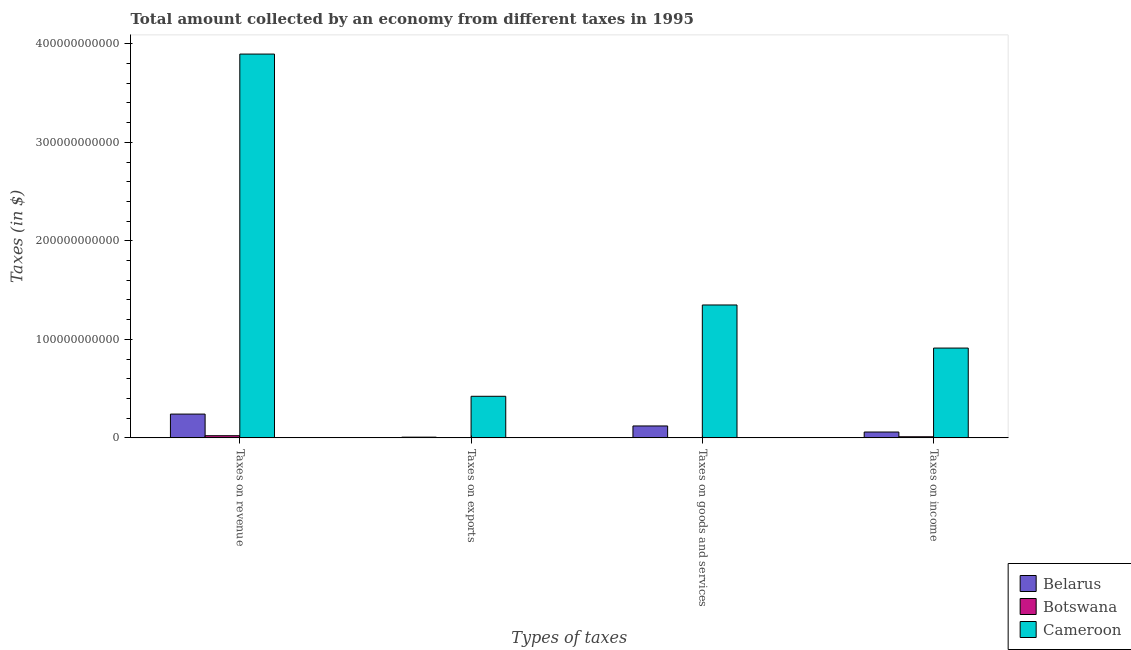How many groups of bars are there?
Your response must be concise. 4. Are the number of bars on each tick of the X-axis equal?
Give a very brief answer. Yes. How many bars are there on the 3rd tick from the left?
Your answer should be very brief. 3. How many bars are there on the 4th tick from the right?
Offer a very short reply. 3. What is the label of the 1st group of bars from the left?
Your answer should be compact. Taxes on revenue. What is the amount collected as tax on revenue in Cameroon?
Your answer should be compact. 3.90e+11. Across all countries, what is the maximum amount collected as tax on income?
Your answer should be very brief. 9.12e+1. Across all countries, what is the minimum amount collected as tax on revenue?
Give a very brief answer. 2.20e+09. In which country was the amount collected as tax on exports maximum?
Offer a terse response. Cameroon. In which country was the amount collected as tax on income minimum?
Ensure brevity in your answer.  Botswana. What is the total amount collected as tax on goods in the graph?
Ensure brevity in your answer.  1.47e+11. What is the difference between the amount collected as tax on exports in Cameroon and that in Belarus?
Make the answer very short. 4.15e+1. What is the difference between the amount collected as tax on exports in Botswana and the amount collected as tax on income in Belarus?
Give a very brief answer. -5.93e+09. What is the average amount collected as tax on exports per country?
Offer a terse response. 1.43e+1. What is the difference between the amount collected as tax on goods and amount collected as tax on exports in Belarus?
Your response must be concise. 1.14e+1. What is the ratio of the amount collected as tax on exports in Botswana to that in Belarus?
Your answer should be compact. 0. Is the amount collected as tax on goods in Cameroon less than that in Botswana?
Ensure brevity in your answer.  No. What is the difference between the highest and the second highest amount collected as tax on income?
Your answer should be compact. 8.52e+1. What is the difference between the highest and the lowest amount collected as tax on exports?
Ensure brevity in your answer.  4.22e+1. Is the sum of the amount collected as tax on goods in Belarus and Botswana greater than the maximum amount collected as tax on income across all countries?
Make the answer very short. No. What does the 1st bar from the left in Taxes on goods and services represents?
Ensure brevity in your answer.  Belarus. What does the 2nd bar from the right in Taxes on revenue represents?
Provide a succinct answer. Botswana. Is it the case that in every country, the sum of the amount collected as tax on revenue and amount collected as tax on exports is greater than the amount collected as tax on goods?
Offer a terse response. Yes. What is the difference between two consecutive major ticks on the Y-axis?
Provide a succinct answer. 1.00e+11. Are the values on the major ticks of Y-axis written in scientific E-notation?
Keep it short and to the point. No. How are the legend labels stacked?
Offer a terse response. Vertical. What is the title of the graph?
Ensure brevity in your answer.  Total amount collected by an economy from different taxes in 1995. Does "Iraq" appear as one of the legend labels in the graph?
Ensure brevity in your answer.  No. What is the label or title of the X-axis?
Ensure brevity in your answer.  Types of taxes. What is the label or title of the Y-axis?
Give a very brief answer. Taxes (in $). What is the Taxes (in $) in Belarus in Taxes on revenue?
Your response must be concise. 2.41e+1. What is the Taxes (in $) in Botswana in Taxes on revenue?
Give a very brief answer. 2.20e+09. What is the Taxes (in $) in Cameroon in Taxes on revenue?
Offer a terse response. 3.90e+11. What is the Taxes (in $) in Belarus in Taxes on exports?
Keep it short and to the point. 7.31e+08. What is the Taxes (in $) in Cameroon in Taxes on exports?
Provide a succinct answer. 4.22e+1. What is the Taxes (in $) of Belarus in Taxes on goods and services?
Offer a terse response. 1.21e+1. What is the Taxes (in $) of Botswana in Taxes on goods and services?
Offer a very short reply. 2.38e+08. What is the Taxes (in $) in Cameroon in Taxes on goods and services?
Make the answer very short. 1.35e+11. What is the Taxes (in $) of Belarus in Taxes on income?
Offer a very short reply. 5.93e+09. What is the Taxes (in $) in Botswana in Taxes on income?
Offer a terse response. 1.13e+09. What is the Taxes (in $) of Cameroon in Taxes on income?
Your response must be concise. 9.12e+1. Across all Types of taxes, what is the maximum Taxes (in $) in Belarus?
Provide a succinct answer. 2.41e+1. Across all Types of taxes, what is the maximum Taxes (in $) in Botswana?
Offer a terse response. 2.20e+09. Across all Types of taxes, what is the maximum Taxes (in $) of Cameroon?
Ensure brevity in your answer.  3.90e+11. Across all Types of taxes, what is the minimum Taxes (in $) in Belarus?
Give a very brief answer. 7.31e+08. Across all Types of taxes, what is the minimum Taxes (in $) in Cameroon?
Provide a succinct answer. 4.22e+1. What is the total Taxes (in $) in Belarus in the graph?
Ensure brevity in your answer.  4.29e+1. What is the total Taxes (in $) in Botswana in the graph?
Provide a short and direct response. 3.56e+09. What is the total Taxes (in $) of Cameroon in the graph?
Your answer should be very brief. 6.58e+11. What is the difference between the Taxes (in $) in Belarus in Taxes on revenue and that in Taxes on exports?
Ensure brevity in your answer.  2.34e+1. What is the difference between the Taxes (in $) of Botswana in Taxes on revenue and that in Taxes on exports?
Provide a short and direct response. 2.20e+09. What is the difference between the Taxes (in $) of Cameroon in Taxes on revenue and that in Taxes on exports?
Keep it short and to the point. 3.47e+11. What is the difference between the Taxes (in $) in Belarus in Taxes on revenue and that in Taxes on goods and services?
Provide a succinct answer. 1.20e+1. What is the difference between the Taxes (in $) of Botswana in Taxes on revenue and that in Taxes on goods and services?
Offer a terse response. 1.96e+09. What is the difference between the Taxes (in $) in Cameroon in Taxes on revenue and that in Taxes on goods and services?
Provide a short and direct response. 2.55e+11. What is the difference between the Taxes (in $) in Belarus in Taxes on revenue and that in Taxes on income?
Your response must be concise. 1.82e+1. What is the difference between the Taxes (in $) in Botswana in Taxes on revenue and that in Taxes on income?
Offer a very short reply. 1.07e+09. What is the difference between the Taxes (in $) of Cameroon in Taxes on revenue and that in Taxes on income?
Ensure brevity in your answer.  2.98e+11. What is the difference between the Taxes (in $) of Belarus in Taxes on exports and that in Taxes on goods and services?
Make the answer very short. -1.14e+1. What is the difference between the Taxes (in $) of Botswana in Taxes on exports and that in Taxes on goods and services?
Your answer should be very brief. -2.37e+08. What is the difference between the Taxes (in $) in Cameroon in Taxes on exports and that in Taxes on goods and services?
Your response must be concise. -9.27e+1. What is the difference between the Taxes (in $) of Belarus in Taxes on exports and that in Taxes on income?
Provide a succinct answer. -5.20e+09. What is the difference between the Taxes (in $) of Botswana in Taxes on exports and that in Taxes on income?
Ensure brevity in your answer.  -1.13e+09. What is the difference between the Taxes (in $) in Cameroon in Taxes on exports and that in Taxes on income?
Give a very brief answer. -4.89e+1. What is the difference between the Taxes (in $) in Belarus in Taxes on goods and services and that in Taxes on income?
Your answer should be very brief. 6.16e+09. What is the difference between the Taxes (in $) of Botswana in Taxes on goods and services and that in Taxes on income?
Offer a terse response. -8.90e+08. What is the difference between the Taxes (in $) in Cameroon in Taxes on goods and services and that in Taxes on income?
Make the answer very short. 4.37e+1. What is the difference between the Taxes (in $) in Belarus in Taxes on revenue and the Taxes (in $) in Botswana in Taxes on exports?
Your answer should be very brief. 2.41e+1. What is the difference between the Taxes (in $) of Belarus in Taxes on revenue and the Taxes (in $) of Cameroon in Taxes on exports?
Make the answer very short. -1.81e+1. What is the difference between the Taxes (in $) of Botswana in Taxes on revenue and the Taxes (in $) of Cameroon in Taxes on exports?
Provide a short and direct response. -4.00e+1. What is the difference between the Taxes (in $) in Belarus in Taxes on revenue and the Taxes (in $) in Botswana in Taxes on goods and services?
Give a very brief answer. 2.39e+1. What is the difference between the Taxes (in $) in Belarus in Taxes on revenue and the Taxes (in $) in Cameroon in Taxes on goods and services?
Offer a terse response. -1.11e+11. What is the difference between the Taxes (in $) in Botswana in Taxes on revenue and the Taxes (in $) in Cameroon in Taxes on goods and services?
Provide a succinct answer. -1.33e+11. What is the difference between the Taxes (in $) in Belarus in Taxes on revenue and the Taxes (in $) in Botswana in Taxes on income?
Your answer should be very brief. 2.30e+1. What is the difference between the Taxes (in $) in Belarus in Taxes on revenue and the Taxes (in $) in Cameroon in Taxes on income?
Your answer should be compact. -6.70e+1. What is the difference between the Taxes (in $) of Botswana in Taxes on revenue and the Taxes (in $) of Cameroon in Taxes on income?
Offer a very short reply. -8.90e+1. What is the difference between the Taxes (in $) in Belarus in Taxes on exports and the Taxes (in $) in Botswana in Taxes on goods and services?
Give a very brief answer. 4.94e+08. What is the difference between the Taxes (in $) in Belarus in Taxes on exports and the Taxes (in $) in Cameroon in Taxes on goods and services?
Give a very brief answer. -1.34e+11. What is the difference between the Taxes (in $) of Botswana in Taxes on exports and the Taxes (in $) of Cameroon in Taxes on goods and services?
Ensure brevity in your answer.  -1.35e+11. What is the difference between the Taxes (in $) of Belarus in Taxes on exports and the Taxes (in $) of Botswana in Taxes on income?
Offer a terse response. -3.96e+08. What is the difference between the Taxes (in $) of Belarus in Taxes on exports and the Taxes (in $) of Cameroon in Taxes on income?
Your response must be concise. -9.04e+1. What is the difference between the Taxes (in $) in Botswana in Taxes on exports and the Taxes (in $) in Cameroon in Taxes on income?
Your answer should be compact. -9.11e+1. What is the difference between the Taxes (in $) of Belarus in Taxes on goods and services and the Taxes (in $) of Botswana in Taxes on income?
Offer a terse response. 1.10e+1. What is the difference between the Taxes (in $) of Belarus in Taxes on goods and services and the Taxes (in $) of Cameroon in Taxes on income?
Give a very brief answer. -7.91e+1. What is the difference between the Taxes (in $) in Botswana in Taxes on goods and services and the Taxes (in $) in Cameroon in Taxes on income?
Give a very brief answer. -9.09e+1. What is the average Taxes (in $) in Belarus per Types of taxes?
Your answer should be compact. 1.07e+1. What is the average Taxes (in $) of Botswana per Types of taxes?
Provide a short and direct response. 8.91e+08. What is the average Taxes (in $) of Cameroon per Types of taxes?
Give a very brief answer. 1.64e+11. What is the difference between the Taxes (in $) of Belarus and Taxes (in $) of Botswana in Taxes on revenue?
Your answer should be compact. 2.19e+1. What is the difference between the Taxes (in $) of Belarus and Taxes (in $) of Cameroon in Taxes on revenue?
Keep it short and to the point. -3.65e+11. What is the difference between the Taxes (in $) of Botswana and Taxes (in $) of Cameroon in Taxes on revenue?
Make the answer very short. -3.87e+11. What is the difference between the Taxes (in $) in Belarus and Taxes (in $) in Botswana in Taxes on exports?
Provide a short and direct response. 7.31e+08. What is the difference between the Taxes (in $) in Belarus and Taxes (in $) in Cameroon in Taxes on exports?
Your answer should be compact. -4.15e+1. What is the difference between the Taxes (in $) in Botswana and Taxes (in $) in Cameroon in Taxes on exports?
Your answer should be very brief. -4.22e+1. What is the difference between the Taxes (in $) in Belarus and Taxes (in $) in Botswana in Taxes on goods and services?
Ensure brevity in your answer.  1.19e+1. What is the difference between the Taxes (in $) in Belarus and Taxes (in $) in Cameroon in Taxes on goods and services?
Keep it short and to the point. -1.23e+11. What is the difference between the Taxes (in $) of Botswana and Taxes (in $) of Cameroon in Taxes on goods and services?
Give a very brief answer. -1.35e+11. What is the difference between the Taxes (in $) of Belarus and Taxes (in $) of Botswana in Taxes on income?
Your response must be concise. 4.81e+09. What is the difference between the Taxes (in $) in Belarus and Taxes (in $) in Cameroon in Taxes on income?
Your response must be concise. -8.52e+1. What is the difference between the Taxes (in $) of Botswana and Taxes (in $) of Cameroon in Taxes on income?
Make the answer very short. -9.00e+1. What is the ratio of the Taxes (in $) in Belarus in Taxes on revenue to that in Taxes on exports?
Make the answer very short. 33.02. What is the ratio of the Taxes (in $) in Botswana in Taxes on revenue to that in Taxes on exports?
Your answer should be compact. 4397.4. What is the ratio of the Taxes (in $) in Cameroon in Taxes on revenue to that in Taxes on exports?
Provide a short and direct response. 9.23. What is the ratio of the Taxes (in $) in Belarus in Taxes on revenue to that in Taxes on goods and services?
Provide a succinct answer. 2. What is the ratio of the Taxes (in $) of Botswana in Taxes on revenue to that in Taxes on goods and services?
Your answer should be compact. 9.25. What is the ratio of the Taxes (in $) in Cameroon in Taxes on revenue to that in Taxes on goods and services?
Provide a short and direct response. 2.89. What is the ratio of the Taxes (in $) of Belarus in Taxes on revenue to that in Taxes on income?
Offer a very short reply. 4.07. What is the ratio of the Taxes (in $) of Botswana in Taxes on revenue to that in Taxes on income?
Provide a short and direct response. 1.95. What is the ratio of the Taxes (in $) of Cameroon in Taxes on revenue to that in Taxes on income?
Offer a very short reply. 4.27. What is the ratio of the Taxes (in $) in Belarus in Taxes on exports to that in Taxes on goods and services?
Make the answer very short. 0.06. What is the ratio of the Taxes (in $) in Botswana in Taxes on exports to that in Taxes on goods and services?
Provide a short and direct response. 0. What is the ratio of the Taxes (in $) of Cameroon in Taxes on exports to that in Taxes on goods and services?
Provide a succinct answer. 0.31. What is the ratio of the Taxes (in $) of Belarus in Taxes on exports to that in Taxes on income?
Offer a terse response. 0.12. What is the ratio of the Taxes (in $) of Cameroon in Taxes on exports to that in Taxes on income?
Offer a terse response. 0.46. What is the ratio of the Taxes (in $) of Belarus in Taxes on goods and services to that in Taxes on income?
Your answer should be very brief. 2.04. What is the ratio of the Taxes (in $) in Botswana in Taxes on goods and services to that in Taxes on income?
Offer a very short reply. 0.21. What is the ratio of the Taxes (in $) in Cameroon in Taxes on goods and services to that in Taxes on income?
Your answer should be very brief. 1.48. What is the difference between the highest and the second highest Taxes (in $) of Belarus?
Offer a terse response. 1.20e+1. What is the difference between the highest and the second highest Taxes (in $) of Botswana?
Ensure brevity in your answer.  1.07e+09. What is the difference between the highest and the second highest Taxes (in $) in Cameroon?
Make the answer very short. 2.55e+11. What is the difference between the highest and the lowest Taxes (in $) in Belarus?
Your answer should be compact. 2.34e+1. What is the difference between the highest and the lowest Taxes (in $) of Botswana?
Your response must be concise. 2.20e+09. What is the difference between the highest and the lowest Taxes (in $) of Cameroon?
Your answer should be compact. 3.47e+11. 